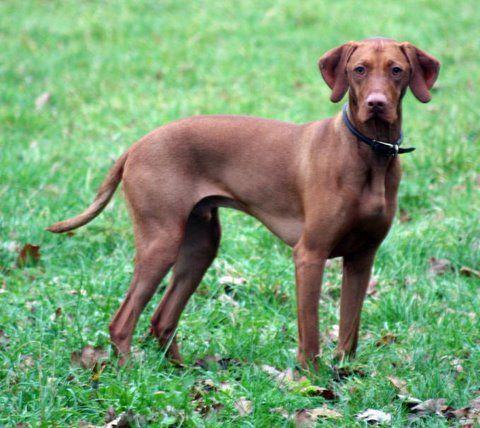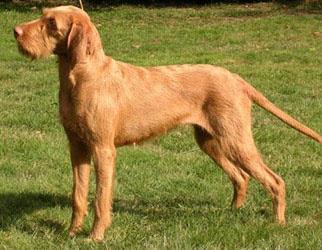The first image is the image on the left, the second image is the image on the right. For the images shown, is this caption "There are two adult dogs" true? Answer yes or no. Yes. The first image is the image on the left, the second image is the image on the right. For the images displayed, is the sentence "At least one of the dogs is carrying something in its mouth." factually correct? Answer yes or no. No. 